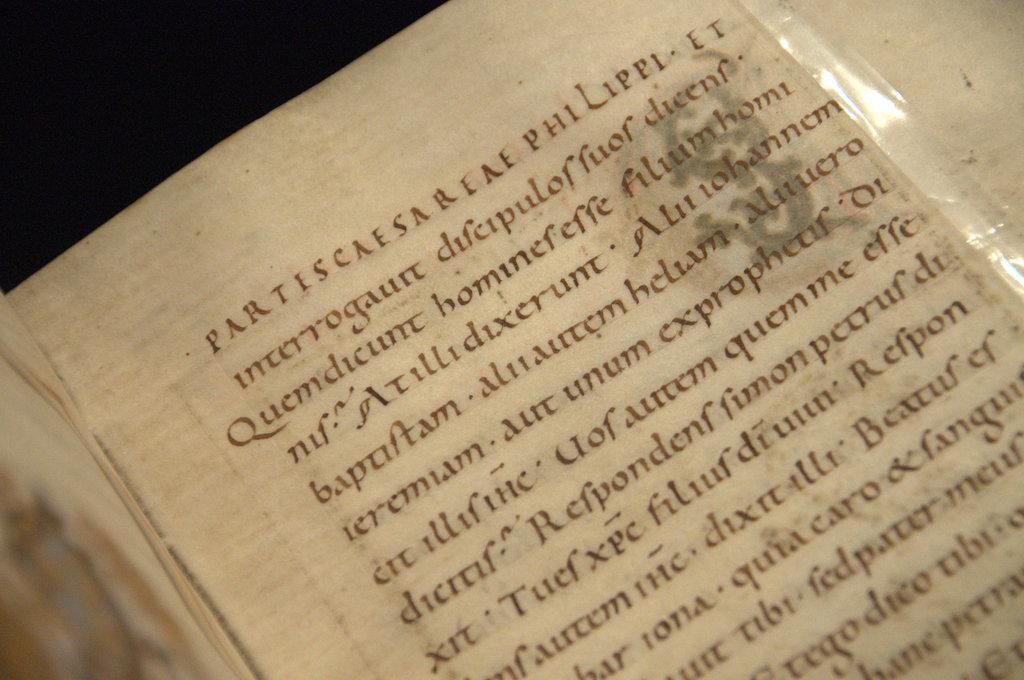What object can be seen in the image? There is a book in the image. Where is the book located? The book is placed on a table. What type of beam is supporting the table in the image? There is no beam visible in the image, and the table's support structure is not mentioned in the provided facts. 